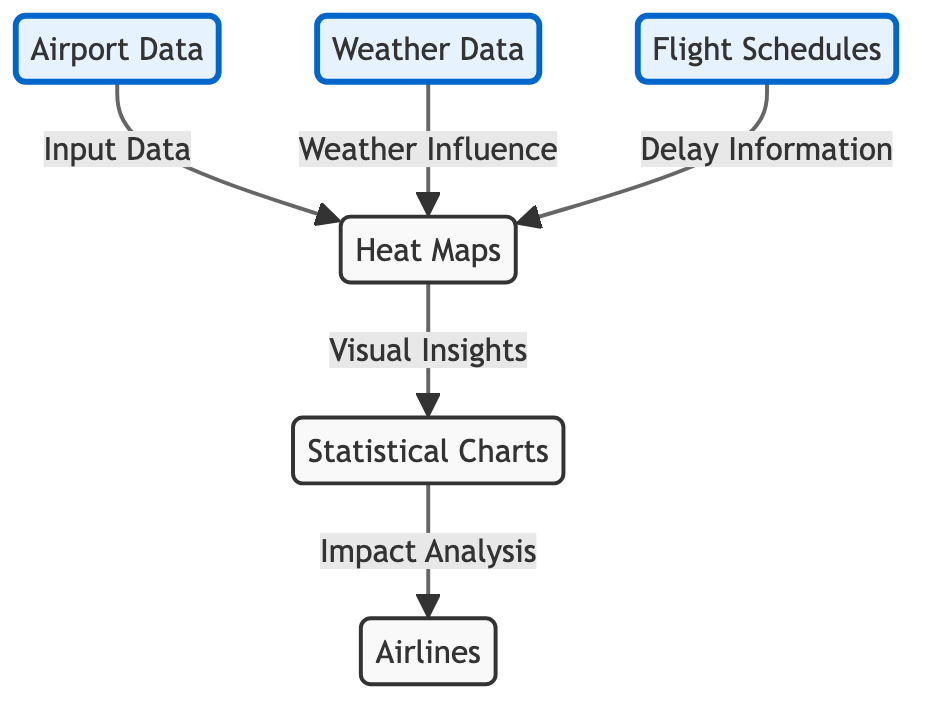What are the two primary input data types for heat maps? The diagram indicates that heat maps receive input from both "Airport Data" and "Weather Data," as represented by the directed edges leading to the heat maps node.
Answer: Airport Data, Weather Data Which node receives input directly from "Flight Schedules"? According to the flow, "Flight Schedules" directly influences "Heat Maps," as indicated by the arrow that connects these two nodes.
Answer: Heat Maps How many data types contribute to the heat maps? The diagram shows that there are three nodes that contribute input to the heat maps: "Airport Data," "Weather Data," and "Flight Schedules." Since there are three directed edges leading to heat maps, the total is three.
Answer: Three What is the final output of the diagram directing towards airlines? The final result of the flow is "Impact Analysis," which is achieved through the "Statistical Charts" node connected to the "Airlines" node in this flowchart.
Answer: Impact Analysis What does "Heat Maps" provide to "Statistical Charts"? The arrows in the diagram show that "Heat Maps" provide "Visual Insights," which are then used in the "Statistical Charts" node for further analysis.
Answer: Visual Insights What influences the creation of heat maps? The diagram specifies that both "Weather Influence" and delay information from "Flight Schedules" influence the creation of heat maps, as shown by the relationships established between these nodes.
Answer: Weather Influence, Delay Information What is the first node in the flow that leads to airlines? Starting from the left of the diagram, the first node that contributes to the analysis directed toward airlines is "Statistical Charts," which is directly connected to the airlines node.
Answer: Statistical Charts How many connections lead to the heat maps? The diagram shows three connections leading to the heat maps: one from "Airport Data," one from "Weather Data," and one from "Flight Schedules," indicating the cumulative input sources for heat maps.
Answer: Three 